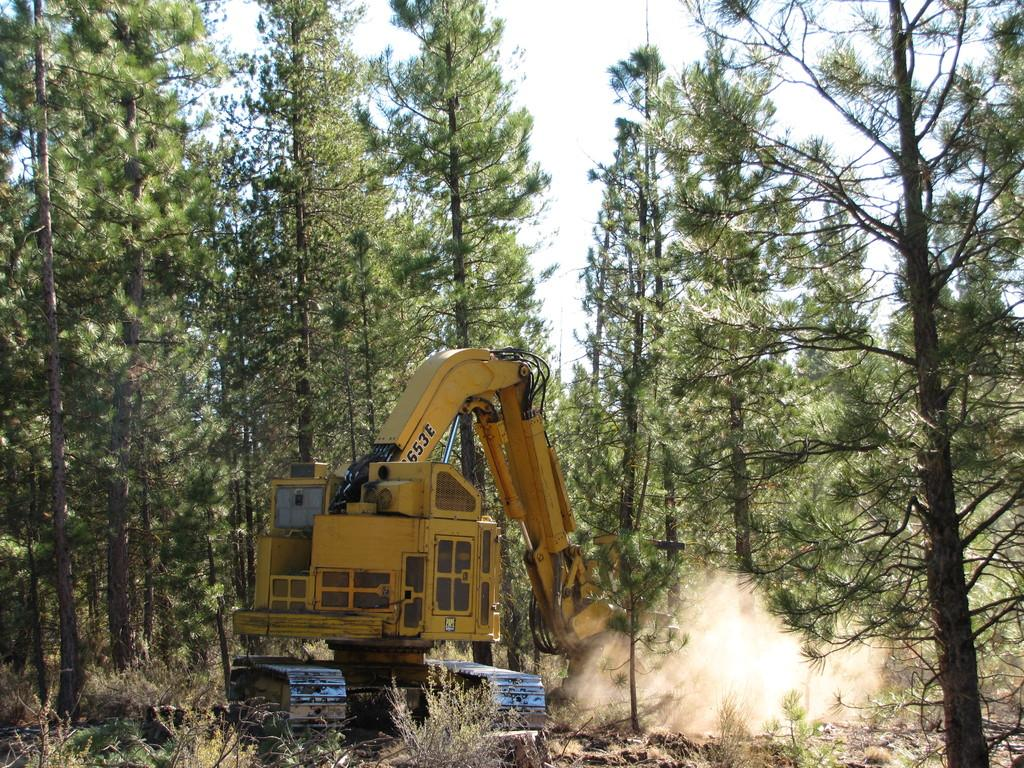What type of vehicle is in the image? There is a vehicle in the image, but the specific type is not mentioned. What color is the vehicle? The vehicle is yellow. What can be seen in the background of the image? There are trees in the background of the image. What color are the trees? The trees are green. What is the color of the sky in the image? The sky is white in the image. Can you see any crackers in the image? There is no mention of crackers in the image, so it cannot be determined if any are present. What type of mist can be seen in the image? There is no mention of mist in the image, so it cannot be determined if any is present. 